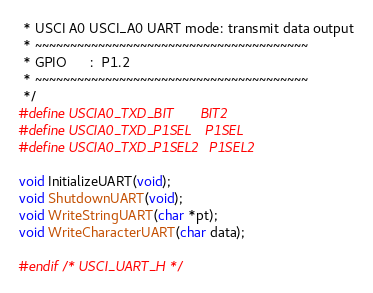Convert code to text. <code><loc_0><loc_0><loc_500><loc_500><_C_> * USCI A0 USCI_A0 UART mode: transmit data output
 * ~~~~~~~~~~~~~~~~~~~~~~~~~~~~~~~~~~~~~~~
 * GPIO      :  P1.2
 * ~~~~~~~~~~~~~~~~~~~~~~~~~~~~~~~~~~~~~~~
 */
#define USCIA0_TXD_BIT		BIT2
#define USCIA0_TXD_P1SEL    P1SEL
#define USCIA0_TXD_P1SEL2   P1SEL2

void InitializeUART(void);
void ShutdownUART(void);
void WriteStringUART(char *pt);
void WriteCharacterUART(char data);
  
#endif /* USCI_UART_H */
</code> 